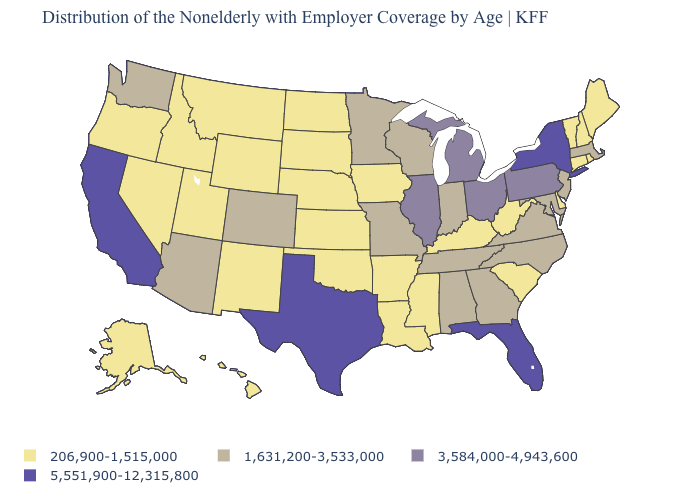Name the states that have a value in the range 5,551,900-12,315,800?
Concise answer only. California, Florida, New York, Texas. What is the value of Iowa?
Give a very brief answer. 206,900-1,515,000. What is the value of Idaho?
Write a very short answer. 206,900-1,515,000. What is the value of South Carolina?
Short answer required. 206,900-1,515,000. Does the map have missing data?
Keep it brief. No. Name the states that have a value in the range 206,900-1,515,000?
Be succinct. Alaska, Arkansas, Connecticut, Delaware, Hawaii, Idaho, Iowa, Kansas, Kentucky, Louisiana, Maine, Mississippi, Montana, Nebraska, Nevada, New Hampshire, New Mexico, North Dakota, Oklahoma, Oregon, Rhode Island, South Carolina, South Dakota, Utah, Vermont, West Virginia, Wyoming. What is the value of Washington?
Give a very brief answer. 1,631,200-3,533,000. Which states have the highest value in the USA?
Keep it brief. California, Florida, New York, Texas. Name the states that have a value in the range 3,584,000-4,943,600?
Concise answer only. Illinois, Michigan, Ohio, Pennsylvania. Does Wisconsin have the highest value in the MidWest?
Answer briefly. No. Name the states that have a value in the range 206,900-1,515,000?
Write a very short answer. Alaska, Arkansas, Connecticut, Delaware, Hawaii, Idaho, Iowa, Kansas, Kentucky, Louisiana, Maine, Mississippi, Montana, Nebraska, Nevada, New Hampshire, New Mexico, North Dakota, Oklahoma, Oregon, Rhode Island, South Carolina, South Dakota, Utah, Vermont, West Virginia, Wyoming. Name the states that have a value in the range 206,900-1,515,000?
Concise answer only. Alaska, Arkansas, Connecticut, Delaware, Hawaii, Idaho, Iowa, Kansas, Kentucky, Louisiana, Maine, Mississippi, Montana, Nebraska, Nevada, New Hampshire, New Mexico, North Dakota, Oklahoma, Oregon, Rhode Island, South Carolina, South Dakota, Utah, Vermont, West Virginia, Wyoming. What is the highest value in states that border Florida?
Concise answer only. 1,631,200-3,533,000. Name the states that have a value in the range 1,631,200-3,533,000?
Give a very brief answer. Alabama, Arizona, Colorado, Georgia, Indiana, Maryland, Massachusetts, Minnesota, Missouri, New Jersey, North Carolina, Tennessee, Virginia, Washington, Wisconsin. 